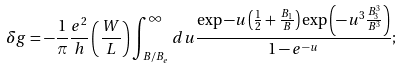<formula> <loc_0><loc_0><loc_500><loc_500>\delta g = - \frac { 1 } { \pi } \frac { e ^ { 2 } } { h } \left ( \frac { W } { L } \right ) \int _ { B / B _ { e } } ^ { \infty } d u \frac { \exp - u \left ( \frac { 1 } { 2 } + \frac { B _ { 1 } } { B } \right ) \exp \left ( - u ^ { 3 } \frac { B _ { 3 } ^ { 3 } } { B ^ { 3 } } \right ) } { 1 - e ^ { - u } } ;</formula> 